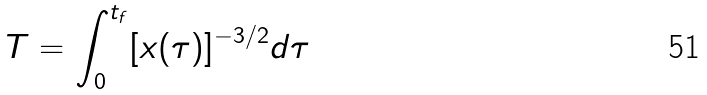Convert formula to latex. <formula><loc_0><loc_0><loc_500><loc_500>T = \int _ { 0 } ^ { t _ { f } } [ x ( \tau ) ] ^ { - 3 / 2 } d \tau</formula> 